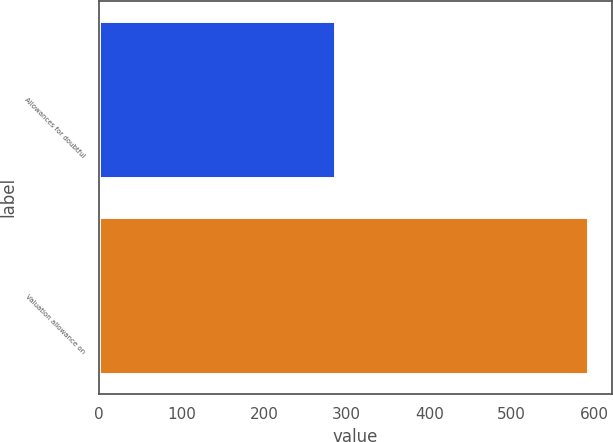Convert chart. <chart><loc_0><loc_0><loc_500><loc_500><bar_chart><fcel>Allowances for doubtful<fcel>Valuation allowance on<nl><fcel>286<fcel>592<nl></chart> 